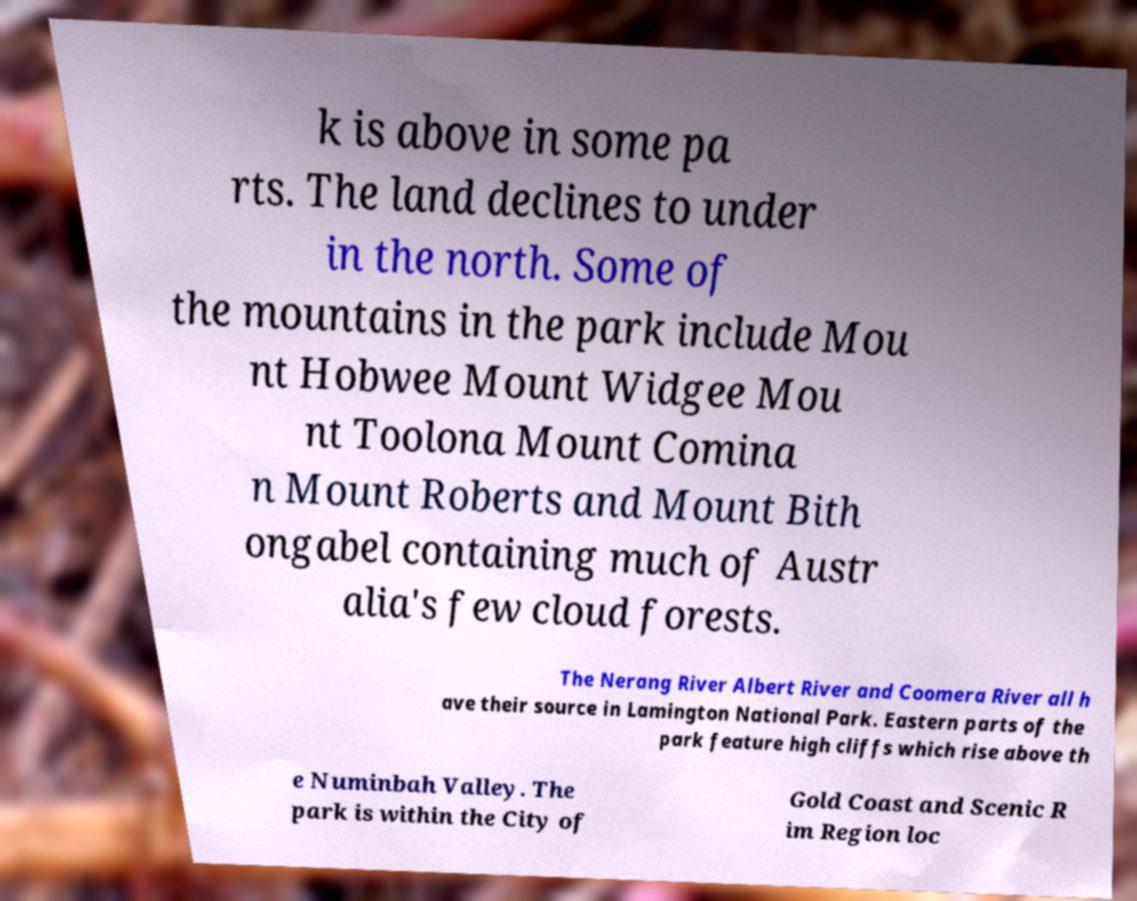I need the written content from this picture converted into text. Can you do that? k is above in some pa rts. The land declines to under in the north. Some of the mountains in the park include Mou nt Hobwee Mount Widgee Mou nt Toolona Mount Comina n Mount Roberts and Mount Bith ongabel containing much of Austr alia's few cloud forests. The Nerang River Albert River and Coomera River all h ave their source in Lamington National Park. Eastern parts of the park feature high cliffs which rise above th e Numinbah Valley. The park is within the City of Gold Coast and Scenic R im Region loc 